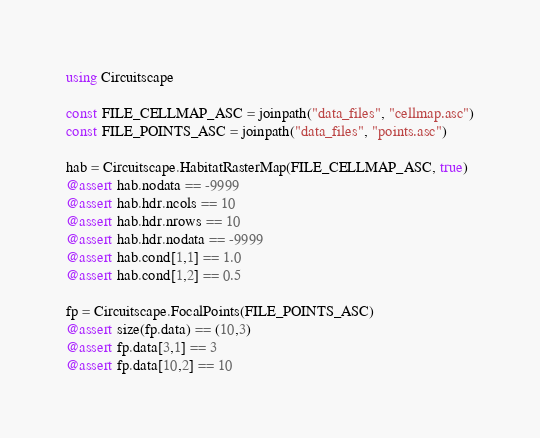Convert code to text. <code><loc_0><loc_0><loc_500><loc_500><_Julia_>using Circuitscape

const FILE_CELLMAP_ASC = joinpath("data_files", "cellmap.asc")
const FILE_POINTS_ASC = joinpath("data_files", "points.asc")

hab = Circuitscape.HabitatRasterMap(FILE_CELLMAP_ASC, true)
@assert hab.nodata == -9999
@assert hab.hdr.ncols == 10
@assert hab.hdr.nrows == 10
@assert hab.hdr.nodata == -9999
@assert hab.cond[1,1] == 1.0
@assert hab.cond[1,2] == 0.5

fp = Circuitscape.FocalPoints(FILE_POINTS_ASC)
@assert size(fp.data) == (10,3)
@assert fp.data[3,1] == 3
@assert fp.data[10,2] == 10


</code> 